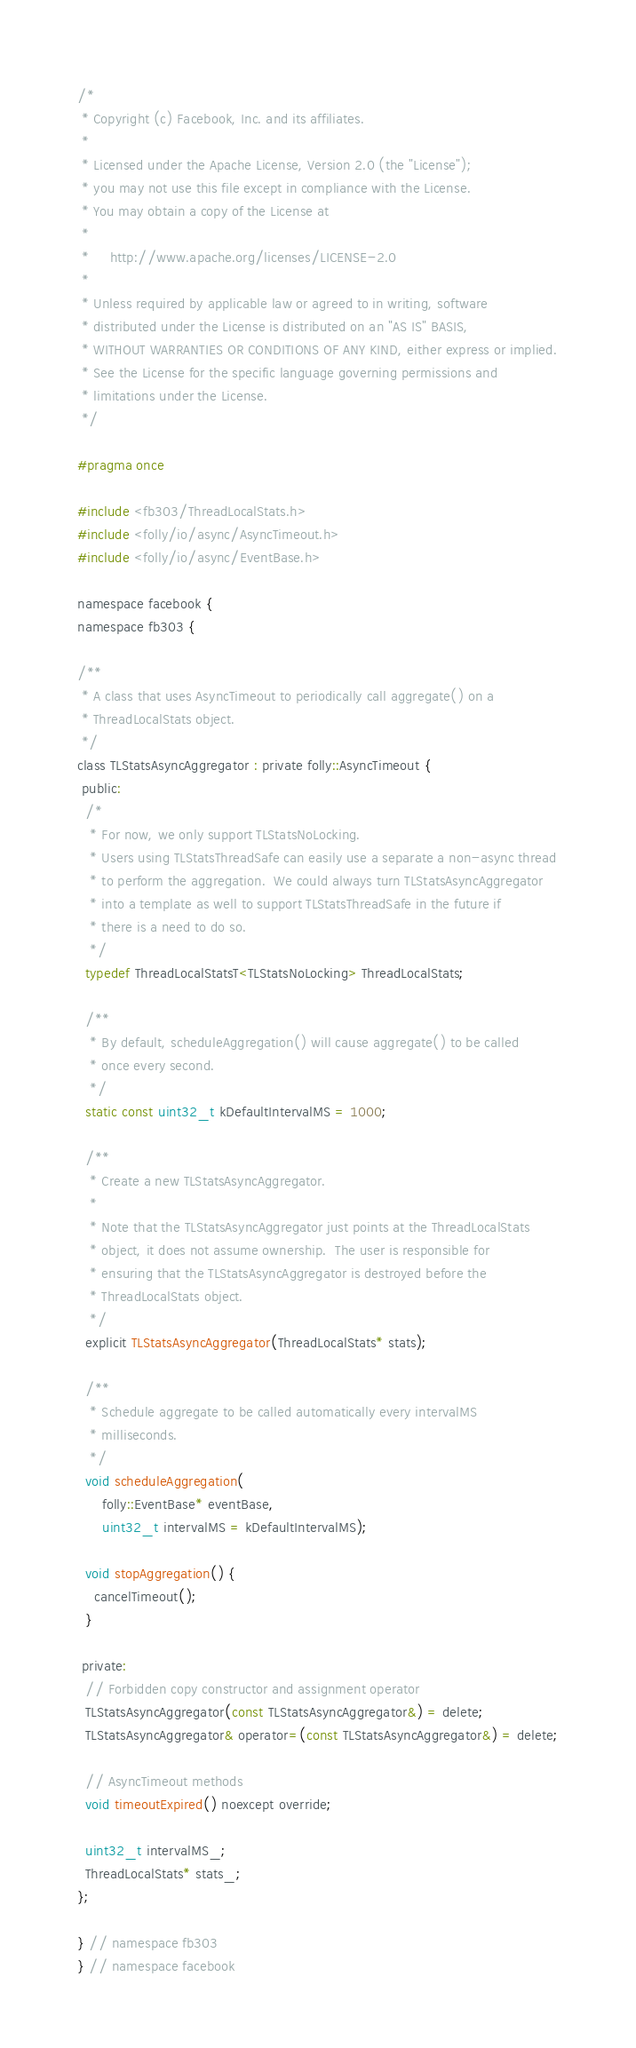Convert code to text. <code><loc_0><loc_0><loc_500><loc_500><_C_>/*
 * Copyright (c) Facebook, Inc. and its affiliates.
 *
 * Licensed under the Apache License, Version 2.0 (the "License");
 * you may not use this file except in compliance with the License.
 * You may obtain a copy of the License at
 *
 *     http://www.apache.org/licenses/LICENSE-2.0
 *
 * Unless required by applicable law or agreed to in writing, software
 * distributed under the License is distributed on an "AS IS" BASIS,
 * WITHOUT WARRANTIES OR CONDITIONS OF ANY KIND, either express or implied.
 * See the License for the specific language governing permissions and
 * limitations under the License.
 */

#pragma once

#include <fb303/ThreadLocalStats.h>
#include <folly/io/async/AsyncTimeout.h>
#include <folly/io/async/EventBase.h>

namespace facebook {
namespace fb303 {

/**
 * A class that uses AsyncTimeout to periodically call aggregate() on a
 * ThreadLocalStats object.
 */
class TLStatsAsyncAggregator : private folly::AsyncTimeout {
 public:
  /*
   * For now, we only support TLStatsNoLocking.
   * Users using TLStatsThreadSafe can easily use a separate a non-async thread
   * to perform the aggregation.  We could always turn TLStatsAsyncAggregator
   * into a template as well to support TLStatsThreadSafe in the future if
   * there is a need to do so.
   */
  typedef ThreadLocalStatsT<TLStatsNoLocking> ThreadLocalStats;

  /**
   * By default, scheduleAggregation() will cause aggregate() to be called
   * once every second.
   */
  static const uint32_t kDefaultIntervalMS = 1000;

  /**
   * Create a new TLStatsAsyncAggregator.
   *
   * Note that the TLStatsAsyncAggregator just points at the ThreadLocalStats
   * object, it does not assume ownership.  The user is responsible for
   * ensuring that the TLStatsAsyncAggregator is destroyed before the
   * ThreadLocalStats object.
   */
  explicit TLStatsAsyncAggregator(ThreadLocalStats* stats);

  /**
   * Schedule aggregate to be called automatically every intervalMS
   * milliseconds.
   */
  void scheduleAggregation(
      folly::EventBase* eventBase,
      uint32_t intervalMS = kDefaultIntervalMS);

  void stopAggregation() {
    cancelTimeout();
  }

 private:
  // Forbidden copy constructor and assignment operator
  TLStatsAsyncAggregator(const TLStatsAsyncAggregator&) = delete;
  TLStatsAsyncAggregator& operator=(const TLStatsAsyncAggregator&) = delete;

  // AsyncTimeout methods
  void timeoutExpired() noexcept override;

  uint32_t intervalMS_;
  ThreadLocalStats* stats_;
};

} // namespace fb303
} // namespace facebook
</code> 